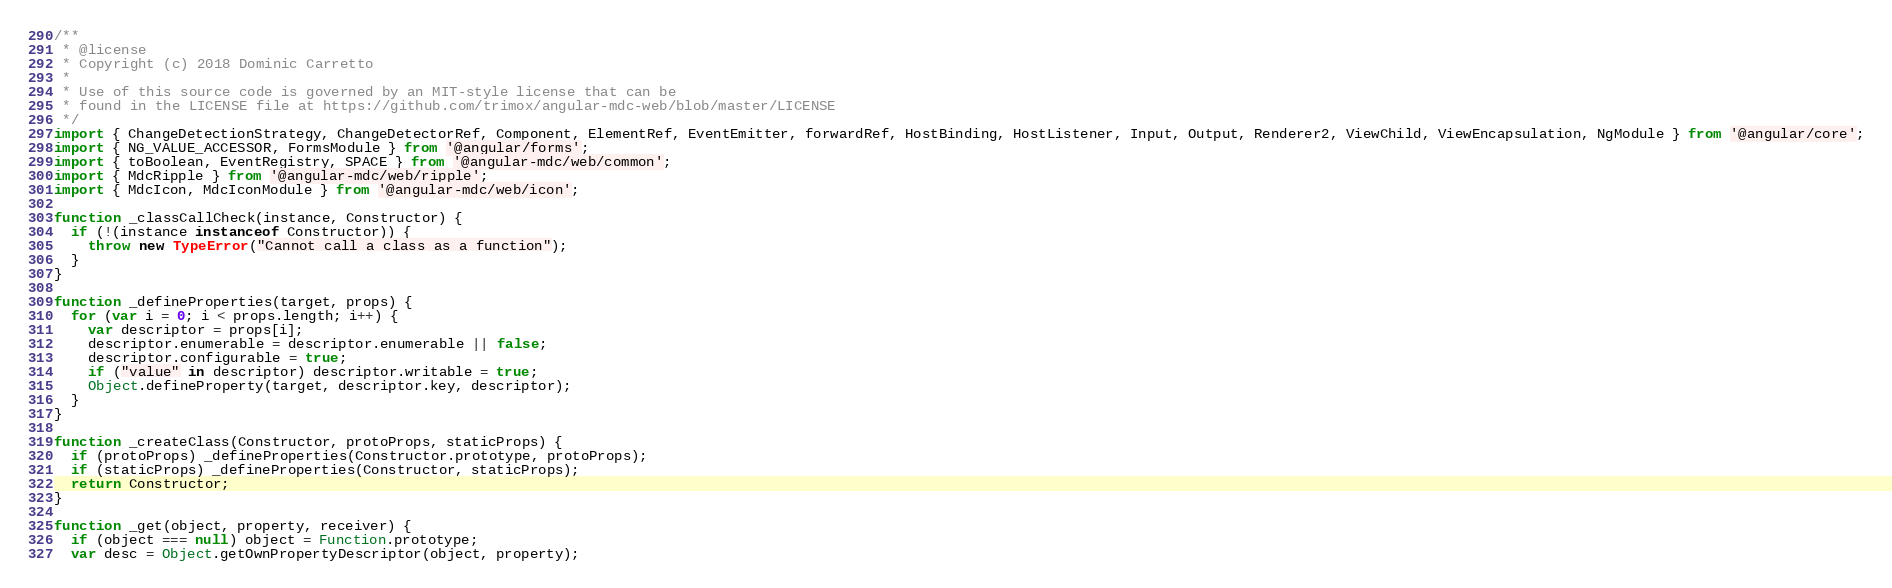<code> <loc_0><loc_0><loc_500><loc_500><_JavaScript_>/**
 * @license
 * Copyright (c) 2018 Dominic Carretto
 *
 * Use of this source code is governed by an MIT-style license that can be
 * found in the LICENSE file at https://github.com/trimox/angular-mdc-web/blob/master/LICENSE
 */
import { ChangeDetectionStrategy, ChangeDetectorRef, Component, ElementRef, EventEmitter, forwardRef, HostBinding, HostListener, Input, Output, Renderer2, ViewChild, ViewEncapsulation, NgModule } from '@angular/core';
import { NG_VALUE_ACCESSOR, FormsModule } from '@angular/forms';
import { toBoolean, EventRegistry, SPACE } from '@angular-mdc/web/common';
import { MdcRipple } from '@angular-mdc/web/ripple';
import { MdcIcon, MdcIconModule } from '@angular-mdc/web/icon';

function _classCallCheck(instance, Constructor) {
  if (!(instance instanceof Constructor)) {
    throw new TypeError("Cannot call a class as a function");
  }
}

function _defineProperties(target, props) {
  for (var i = 0; i < props.length; i++) {
    var descriptor = props[i];
    descriptor.enumerable = descriptor.enumerable || false;
    descriptor.configurable = true;
    if ("value" in descriptor) descriptor.writable = true;
    Object.defineProperty(target, descriptor.key, descriptor);
  }
}

function _createClass(Constructor, protoProps, staticProps) {
  if (protoProps) _defineProperties(Constructor.prototype, protoProps);
  if (staticProps) _defineProperties(Constructor, staticProps);
  return Constructor;
}

function _get(object, property, receiver) {
  if (object === null) object = Function.prototype;
  var desc = Object.getOwnPropertyDescriptor(object, property);
</code> 